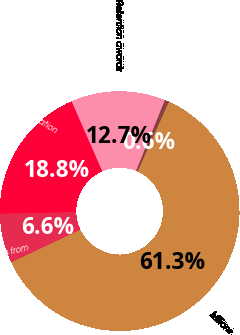Convert chart to OTSL. <chart><loc_0><loc_0><loc_500><loc_500><pie_chart><fcel>Millions<fcel>Stock options<fcel>Retention awards<fcel>Total stock-based compensation<fcel>Excess tax benefits from<nl><fcel>61.27%<fcel>0.58%<fcel>12.72%<fcel>18.79%<fcel>6.65%<nl></chart> 